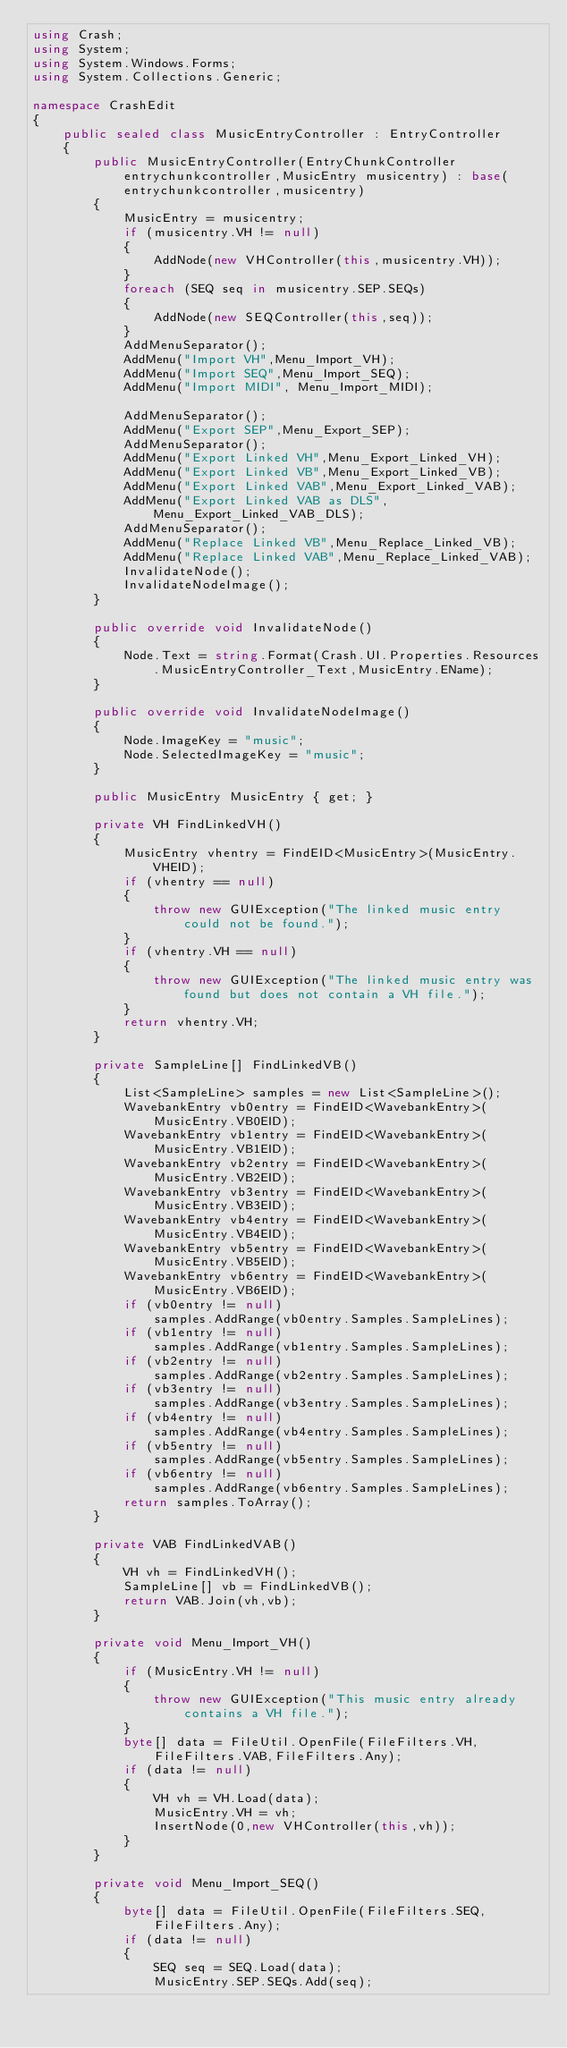Convert code to text. <code><loc_0><loc_0><loc_500><loc_500><_C#_>using Crash;
using System;
using System.Windows.Forms;
using System.Collections.Generic;

namespace CrashEdit
{
    public sealed class MusicEntryController : EntryController
    {
        public MusicEntryController(EntryChunkController entrychunkcontroller,MusicEntry musicentry) : base(entrychunkcontroller,musicentry)
        {
            MusicEntry = musicentry;
            if (musicentry.VH != null)
            {
                AddNode(new VHController(this,musicentry.VH));
            }
            foreach (SEQ seq in musicentry.SEP.SEQs)
            {
                AddNode(new SEQController(this,seq));
            }
            AddMenuSeparator();
            AddMenu("Import VH",Menu_Import_VH);
            AddMenu("Import SEQ",Menu_Import_SEQ);
            AddMenu("Import MIDI", Menu_Import_MIDI);

            AddMenuSeparator();
            AddMenu("Export SEP",Menu_Export_SEP);
            AddMenuSeparator();
            AddMenu("Export Linked VH",Menu_Export_Linked_VH);
            AddMenu("Export Linked VB",Menu_Export_Linked_VB);
            AddMenu("Export Linked VAB",Menu_Export_Linked_VAB);
            AddMenu("Export Linked VAB as DLS",Menu_Export_Linked_VAB_DLS);
            AddMenuSeparator();
            AddMenu("Replace Linked VB",Menu_Replace_Linked_VB);
            AddMenu("Replace Linked VAB",Menu_Replace_Linked_VAB);
            InvalidateNode();
            InvalidateNodeImage();
        }

        public override void InvalidateNode()
        {
            Node.Text = string.Format(Crash.UI.Properties.Resources.MusicEntryController_Text,MusicEntry.EName);
        }

        public override void InvalidateNodeImage()
        {
            Node.ImageKey = "music";
            Node.SelectedImageKey = "music";
        }

        public MusicEntry MusicEntry { get; }

        private VH FindLinkedVH()
        {
            MusicEntry vhentry = FindEID<MusicEntry>(MusicEntry.VHEID);
            if (vhentry == null)
            {
                throw new GUIException("The linked music entry could not be found.");
            }
            if (vhentry.VH == null)
            {
                throw new GUIException("The linked music entry was found but does not contain a VH file.");
            }
            return vhentry.VH;
        }

        private SampleLine[] FindLinkedVB()
        {
            List<SampleLine> samples = new List<SampleLine>();
            WavebankEntry vb0entry = FindEID<WavebankEntry>(MusicEntry.VB0EID);
            WavebankEntry vb1entry = FindEID<WavebankEntry>(MusicEntry.VB1EID);
            WavebankEntry vb2entry = FindEID<WavebankEntry>(MusicEntry.VB2EID);
            WavebankEntry vb3entry = FindEID<WavebankEntry>(MusicEntry.VB3EID);
            WavebankEntry vb4entry = FindEID<WavebankEntry>(MusicEntry.VB4EID);
            WavebankEntry vb5entry = FindEID<WavebankEntry>(MusicEntry.VB5EID);
            WavebankEntry vb6entry = FindEID<WavebankEntry>(MusicEntry.VB6EID);
            if (vb0entry != null)
                samples.AddRange(vb0entry.Samples.SampleLines);
            if (vb1entry != null)
                samples.AddRange(vb1entry.Samples.SampleLines);
            if (vb2entry != null)
                samples.AddRange(vb2entry.Samples.SampleLines);
            if (vb3entry != null)
                samples.AddRange(vb3entry.Samples.SampleLines);
            if (vb4entry != null)
                samples.AddRange(vb4entry.Samples.SampleLines);
            if (vb5entry != null)
                samples.AddRange(vb5entry.Samples.SampleLines);
            if (vb6entry != null)
                samples.AddRange(vb6entry.Samples.SampleLines);
            return samples.ToArray();
        }

        private VAB FindLinkedVAB()
        {
            VH vh = FindLinkedVH();
            SampleLine[] vb = FindLinkedVB();
            return VAB.Join(vh,vb);
        }

        private void Menu_Import_VH()
        {
            if (MusicEntry.VH != null)
            {
                throw new GUIException("This music entry already contains a VH file.");
            }
            byte[] data = FileUtil.OpenFile(FileFilters.VH,FileFilters.VAB,FileFilters.Any);
            if (data != null)
            {
                VH vh = VH.Load(data);
                MusicEntry.VH = vh;
                InsertNode(0,new VHController(this,vh));
            }
        }

        private void Menu_Import_SEQ()
        {
            byte[] data = FileUtil.OpenFile(FileFilters.SEQ,FileFilters.Any);
            if (data != null)
            {
                SEQ seq = SEQ.Load(data);
                MusicEntry.SEP.SEQs.Add(seq);</code> 